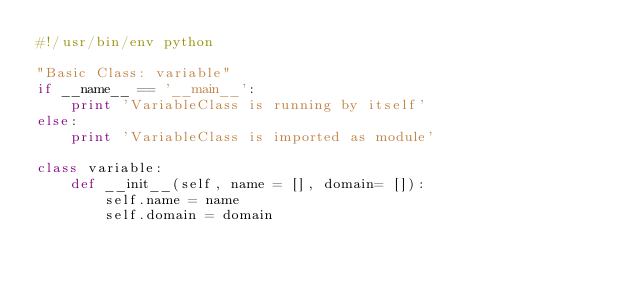Convert code to text. <code><loc_0><loc_0><loc_500><loc_500><_Python_>#!/usr/bin/env python

"Basic Class: variable"
if __name__ == '__main__':
    print 'VariableClass is running by itself'
else:
    print 'VariableClass is imported as module'
	
class variable: 
	def __init__(self, name = [], domain= []): 
		self.name = name 
		self.domain = domain </code> 